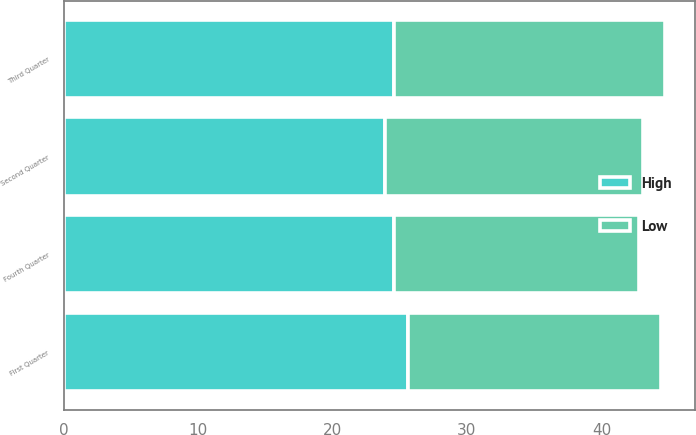Convert chart to OTSL. <chart><loc_0><loc_0><loc_500><loc_500><stacked_bar_chart><ecel><fcel>First Quarter<fcel>Second Quarter<fcel>Third Quarter<fcel>Fourth Quarter<nl><fcel>High<fcel>25.58<fcel>23.87<fcel>24.57<fcel>24.58<nl><fcel>Low<fcel>18.86<fcel>19.24<fcel>20.13<fcel>18.2<nl></chart> 